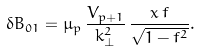Convert formula to latex. <formula><loc_0><loc_0><loc_500><loc_500>\delta B _ { 0 1 } = { \mu _ { p } } \, \frac { V _ { p + 1 } } { k _ { \bot } ^ { 2 } } \, \frac { x \, f } { \sqrt { 1 - f ^ { 2 } } } .</formula> 